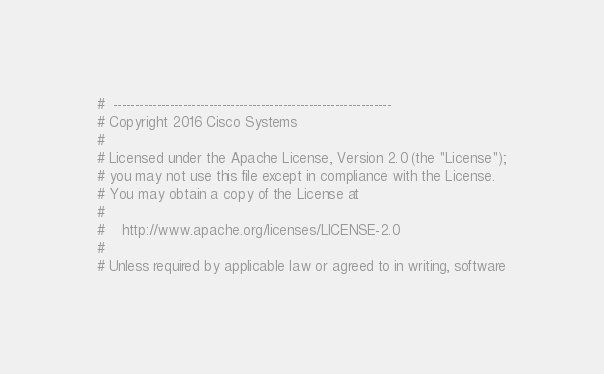<code> <loc_0><loc_0><loc_500><loc_500><_Python_>#  ----------------------------------------------------------------
# Copyright 2016 Cisco Systems
#
# Licensed under the Apache License, Version 2.0 (the "License");
# you may not use this file except in compliance with the License.
# You may obtain a copy of the License at
#
#    http://www.apache.org/licenses/LICENSE-2.0
#
# Unless required by applicable law or agreed to in writing, software</code> 